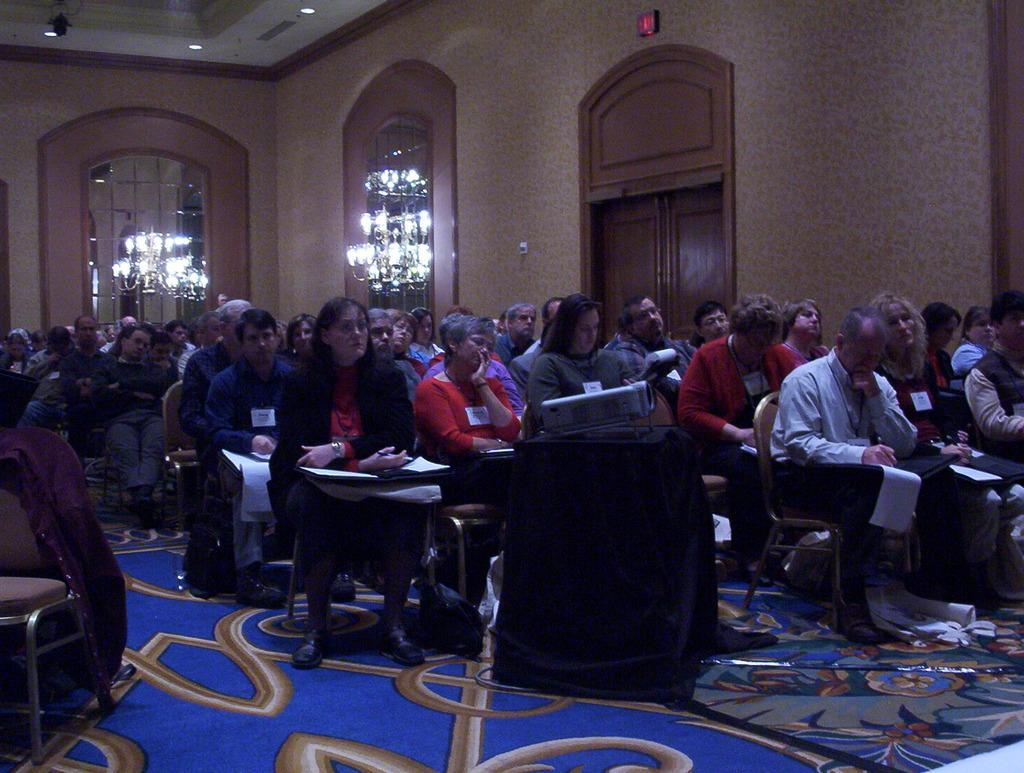In one or two sentences, can you explain what this image depicts? In this image we can see people sitting on chairs. In the background of the image there is wall. There are lights. There is a door. At the top of the image there is ceiling with lights. At the bottom of the image there is carpet. 